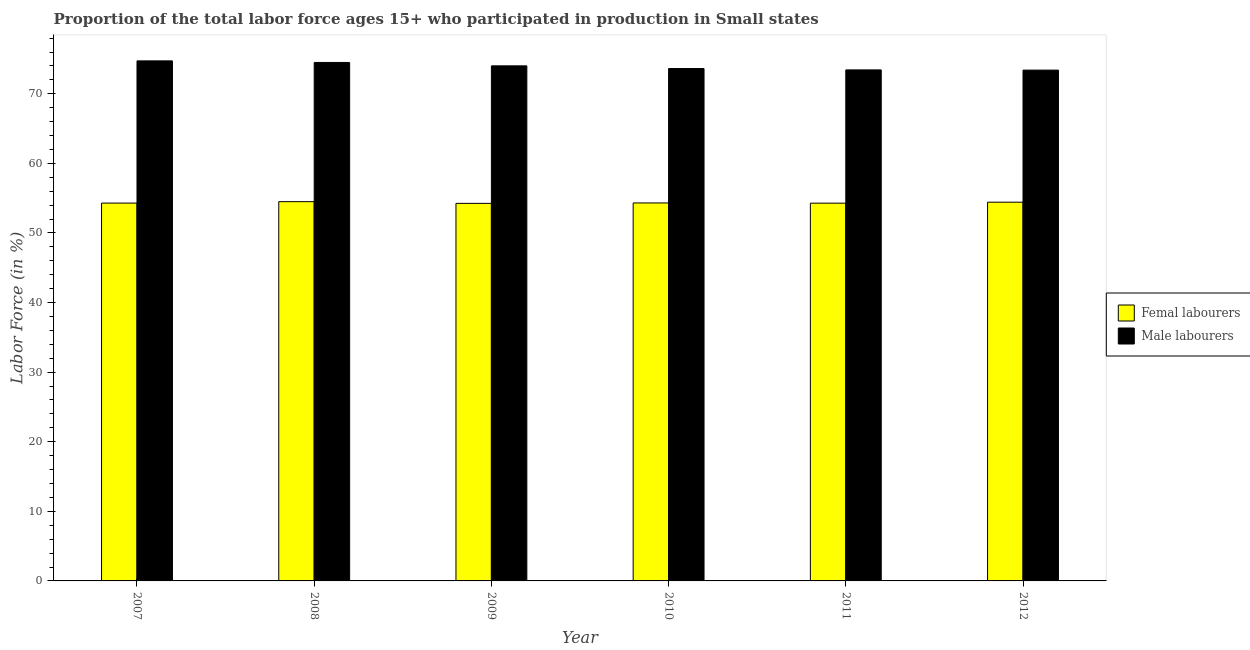How many different coloured bars are there?
Provide a short and direct response. 2. How many groups of bars are there?
Your answer should be very brief. 6. Are the number of bars per tick equal to the number of legend labels?
Keep it short and to the point. Yes. How many bars are there on the 3rd tick from the left?
Ensure brevity in your answer.  2. In how many cases, is the number of bars for a given year not equal to the number of legend labels?
Offer a terse response. 0. What is the percentage of female labor force in 2008?
Your answer should be compact. 54.5. Across all years, what is the maximum percentage of male labour force?
Ensure brevity in your answer.  74.73. Across all years, what is the minimum percentage of male labour force?
Your response must be concise. 73.4. In which year was the percentage of female labor force minimum?
Provide a succinct answer. 2009. What is the total percentage of male labour force in the graph?
Ensure brevity in your answer.  443.71. What is the difference between the percentage of female labor force in 2009 and that in 2010?
Your answer should be very brief. -0.06. What is the difference between the percentage of male labour force in 2010 and the percentage of female labor force in 2007?
Offer a very short reply. -1.1. What is the average percentage of female labor force per year?
Provide a succinct answer. 54.34. In how many years, is the percentage of male labour force greater than 26 %?
Give a very brief answer. 6. What is the ratio of the percentage of female labor force in 2010 to that in 2012?
Keep it short and to the point. 1. Is the difference between the percentage of male labour force in 2008 and 2009 greater than the difference between the percentage of female labor force in 2008 and 2009?
Give a very brief answer. No. What is the difference between the highest and the second highest percentage of female labor force?
Ensure brevity in your answer.  0.07. What is the difference between the highest and the lowest percentage of female labor force?
Keep it short and to the point. 0.24. What does the 2nd bar from the left in 2010 represents?
Offer a terse response. Male labourers. What does the 2nd bar from the right in 2012 represents?
Your answer should be compact. Femal labourers. How many bars are there?
Provide a short and direct response. 12. Are all the bars in the graph horizontal?
Your response must be concise. No. Does the graph contain any zero values?
Your answer should be very brief. No. Where does the legend appear in the graph?
Offer a terse response. Center right. What is the title of the graph?
Offer a very short reply. Proportion of the total labor force ages 15+ who participated in production in Small states. What is the label or title of the Y-axis?
Provide a short and direct response. Labor Force (in %). What is the Labor Force (in %) in Femal labourers in 2007?
Provide a succinct answer. 54.29. What is the Labor Force (in %) of Male labourers in 2007?
Keep it short and to the point. 74.73. What is the Labor Force (in %) of Femal labourers in 2008?
Make the answer very short. 54.5. What is the Labor Force (in %) of Male labourers in 2008?
Keep it short and to the point. 74.5. What is the Labor Force (in %) in Femal labourers in 2009?
Your answer should be very brief. 54.25. What is the Labor Force (in %) in Male labourers in 2009?
Keep it short and to the point. 74.01. What is the Labor Force (in %) in Femal labourers in 2010?
Offer a very short reply. 54.31. What is the Labor Force (in %) in Male labourers in 2010?
Keep it short and to the point. 73.63. What is the Labor Force (in %) of Femal labourers in 2011?
Offer a very short reply. 54.28. What is the Labor Force (in %) in Male labourers in 2011?
Keep it short and to the point. 73.43. What is the Labor Force (in %) of Femal labourers in 2012?
Provide a short and direct response. 54.42. What is the Labor Force (in %) of Male labourers in 2012?
Your answer should be very brief. 73.4. Across all years, what is the maximum Labor Force (in %) in Femal labourers?
Offer a terse response. 54.5. Across all years, what is the maximum Labor Force (in %) of Male labourers?
Your answer should be compact. 74.73. Across all years, what is the minimum Labor Force (in %) of Femal labourers?
Provide a short and direct response. 54.25. Across all years, what is the minimum Labor Force (in %) of Male labourers?
Provide a succinct answer. 73.4. What is the total Labor Force (in %) in Femal labourers in the graph?
Provide a short and direct response. 326.07. What is the total Labor Force (in %) in Male labourers in the graph?
Offer a very short reply. 443.71. What is the difference between the Labor Force (in %) in Femal labourers in 2007 and that in 2008?
Give a very brief answer. -0.2. What is the difference between the Labor Force (in %) in Male labourers in 2007 and that in 2008?
Keep it short and to the point. 0.23. What is the difference between the Labor Force (in %) of Male labourers in 2007 and that in 2009?
Give a very brief answer. 0.72. What is the difference between the Labor Force (in %) in Femal labourers in 2007 and that in 2010?
Give a very brief answer. -0.02. What is the difference between the Labor Force (in %) in Male labourers in 2007 and that in 2010?
Your answer should be very brief. 1.1. What is the difference between the Labor Force (in %) of Femal labourers in 2007 and that in 2011?
Ensure brevity in your answer.  0.01. What is the difference between the Labor Force (in %) of Male labourers in 2007 and that in 2011?
Your answer should be compact. 1.3. What is the difference between the Labor Force (in %) of Femal labourers in 2007 and that in 2012?
Give a very brief answer. -0.13. What is the difference between the Labor Force (in %) in Male labourers in 2007 and that in 2012?
Your answer should be compact. 1.33. What is the difference between the Labor Force (in %) in Femal labourers in 2008 and that in 2009?
Offer a very short reply. 0.24. What is the difference between the Labor Force (in %) in Male labourers in 2008 and that in 2009?
Your answer should be compact. 0.49. What is the difference between the Labor Force (in %) of Femal labourers in 2008 and that in 2010?
Ensure brevity in your answer.  0.18. What is the difference between the Labor Force (in %) in Male labourers in 2008 and that in 2010?
Make the answer very short. 0.87. What is the difference between the Labor Force (in %) of Femal labourers in 2008 and that in 2011?
Your answer should be very brief. 0.22. What is the difference between the Labor Force (in %) of Male labourers in 2008 and that in 2011?
Keep it short and to the point. 1.07. What is the difference between the Labor Force (in %) in Femal labourers in 2008 and that in 2012?
Ensure brevity in your answer.  0.07. What is the difference between the Labor Force (in %) of Male labourers in 2008 and that in 2012?
Your response must be concise. 1.1. What is the difference between the Labor Force (in %) of Femal labourers in 2009 and that in 2010?
Your answer should be compact. -0.06. What is the difference between the Labor Force (in %) in Male labourers in 2009 and that in 2010?
Your response must be concise. 0.38. What is the difference between the Labor Force (in %) of Femal labourers in 2009 and that in 2011?
Your answer should be very brief. -0.03. What is the difference between the Labor Force (in %) of Male labourers in 2009 and that in 2011?
Your answer should be very brief. 0.58. What is the difference between the Labor Force (in %) in Femal labourers in 2009 and that in 2012?
Provide a succinct answer. -0.17. What is the difference between the Labor Force (in %) in Male labourers in 2009 and that in 2012?
Your response must be concise. 0.61. What is the difference between the Labor Force (in %) of Femal labourers in 2010 and that in 2011?
Provide a short and direct response. 0.03. What is the difference between the Labor Force (in %) of Male labourers in 2010 and that in 2011?
Offer a terse response. 0.2. What is the difference between the Labor Force (in %) in Femal labourers in 2010 and that in 2012?
Provide a succinct answer. -0.11. What is the difference between the Labor Force (in %) of Male labourers in 2010 and that in 2012?
Ensure brevity in your answer.  0.23. What is the difference between the Labor Force (in %) of Femal labourers in 2011 and that in 2012?
Make the answer very short. -0.14. What is the difference between the Labor Force (in %) of Male labourers in 2011 and that in 2012?
Ensure brevity in your answer.  0.03. What is the difference between the Labor Force (in %) of Femal labourers in 2007 and the Labor Force (in %) of Male labourers in 2008?
Offer a very short reply. -20.21. What is the difference between the Labor Force (in %) of Femal labourers in 2007 and the Labor Force (in %) of Male labourers in 2009?
Provide a short and direct response. -19.72. What is the difference between the Labor Force (in %) in Femal labourers in 2007 and the Labor Force (in %) in Male labourers in 2010?
Provide a succinct answer. -19.33. What is the difference between the Labor Force (in %) in Femal labourers in 2007 and the Labor Force (in %) in Male labourers in 2011?
Your answer should be compact. -19.14. What is the difference between the Labor Force (in %) of Femal labourers in 2007 and the Labor Force (in %) of Male labourers in 2012?
Your response must be concise. -19.11. What is the difference between the Labor Force (in %) in Femal labourers in 2008 and the Labor Force (in %) in Male labourers in 2009?
Keep it short and to the point. -19.51. What is the difference between the Labor Force (in %) in Femal labourers in 2008 and the Labor Force (in %) in Male labourers in 2010?
Your response must be concise. -19.13. What is the difference between the Labor Force (in %) in Femal labourers in 2008 and the Labor Force (in %) in Male labourers in 2011?
Provide a short and direct response. -18.93. What is the difference between the Labor Force (in %) of Femal labourers in 2008 and the Labor Force (in %) of Male labourers in 2012?
Offer a terse response. -18.9. What is the difference between the Labor Force (in %) in Femal labourers in 2009 and the Labor Force (in %) in Male labourers in 2010?
Offer a very short reply. -19.37. What is the difference between the Labor Force (in %) of Femal labourers in 2009 and the Labor Force (in %) of Male labourers in 2011?
Give a very brief answer. -19.18. What is the difference between the Labor Force (in %) in Femal labourers in 2009 and the Labor Force (in %) in Male labourers in 2012?
Make the answer very short. -19.15. What is the difference between the Labor Force (in %) of Femal labourers in 2010 and the Labor Force (in %) of Male labourers in 2011?
Ensure brevity in your answer.  -19.12. What is the difference between the Labor Force (in %) of Femal labourers in 2010 and the Labor Force (in %) of Male labourers in 2012?
Make the answer very short. -19.09. What is the difference between the Labor Force (in %) of Femal labourers in 2011 and the Labor Force (in %) of Male labourers in 2012?
Offer a very short reply. -19.12. What is the average Labor Force (in %) in Femal labourers per year?
Your answer should be very brief. 54.34. What is the average Labor Force (in %) in Male labourers per year?
Provide a short and direct response. 73.95. In the year 2007, what is the difference between the Labor Force (in %) of Femal labourers and Labor Force (in %) of Male labourers?
Your answer should be very brief. -20.43. In the year 2008, what is the difference between the Labor Force (in %) in Femal labourers and Labor Force (in %) in Male labourers?
Keep it short and to the point. -20. In the year 2009, what is the difference between the Labor Force (in %) of Femal labourers and Labor Force (in %) of Male labourers?
Ensure brevity in your answer.  -19.76. In the year 2010, what is the difference between the Labor Force (in %) in Femal labourers and Labor Force (in %) in Male labourers?
Ensure brevity in your answer.  -19.31. In the year 2011, what is the difference between the Labor Force (in %) of Femal labourers and Labor Force (in %) of Male labourers?
Offer a terse response. -19.15. In the year 2012, what is the difference between the Labor Force (in %) of Femal labourers and Labor Force (in %) of Male labourers?
Give a very brief answer. -18.98. What is the ratio of the Labor Force (in %) in Male labourers in 2007 to that in 2009?
Provide a succinct answer. 1.01. What is the ratio of the Labor Force (in %) of Femal labourers in 2007 to that in 2010?
Your answer should be compact. 1. What is the ratio of the Labor Force (in %) in Male labourers in 2007 to that in 2010?
Offer a very short reply. 1.01. What is the ratio of the Labor Force (in %) of Male labourers in 2007 to that in 2011?
Make the answer very short. 1.02. What is the ratio of the Labor Force (in %) of Femal labourers in 2007 to that in 2012?
Offer a terse response. 1. What is the ratio of the Labor Force (in %) in Male labourers in 2007 to that in 2012?
Keep it short and to the point. 1.02. What is the ratio of the Labor Force (in %) in Femal labourers in 2008 to that in 2009?
Offer a terse response. 1. What is the ratio of the Labor Force (in %) of Male labourers in 2008 to that in 2009?
Your response must be concise. 1.01. What is the ratio of the Labor Force (in %) in Male labourers in 2008 to that in 2010?
Offer a terse response. 1.01. What is the ratio of the Labor Force (in %) in Femal labourers in 2008 to that in 2011?
Offer a very short reply. 1. What is the ratio of the Labor Force (in %) of Male labourers in 2008 to that in 2011?
Keep it short and to the point. 1.01. What is the ratio of the Labor Force (in %) of Femal labourers in 2008 to that in 2012?
Your response must be concise. 1. What is the ratio of the Labor Force (in %) of Femal labourers in 2009 to that in 2010?
Ensure brevity in your answer.  1. What is the ratio of the Labor Force (in %) in Male labourers in 2009 to that in 2010?
Offer a terse response. 1.01. What is the ratio of the Labor Force (in %) in Male labourers in 2009 to that in 2011?
Your response must be concise. 1.01. What is the ratio of the Labor Force (in %) in Femal labourers in 2009 to that in 2012?
Your answer should be compact. 1. What is the ratio of the Labor Force (in %) in Male labourers in 2009 to that in 2012?
Provide a short and direct response. 1.01. What is the ratio of the Labor Force (in %) in Male labourers in 2010 to that in 2011?
Make the answer very short. 1. What is the ratio of the Labor Force (in %) in Femal labourers in 2011 to that in 2012?
Give a very brief answer. 1. What is the difference between the highest and the second highest Labor Force (in %) in Femal labourers?
Provide a succinct answer. 0.07. What is the difference between the highest and the second highest Labor Force (in %) of Male labourers?
Provide a short and direct response. 0.23. What is the difference between the highest and the lowest Labor Force (in %) of Femal labourers?
Ensure brevity in your answer.  0.24. What is the difference between the highest and the lowest Labor Force (in %) of Male labourers?
Offer a very short reply. 1.33. 